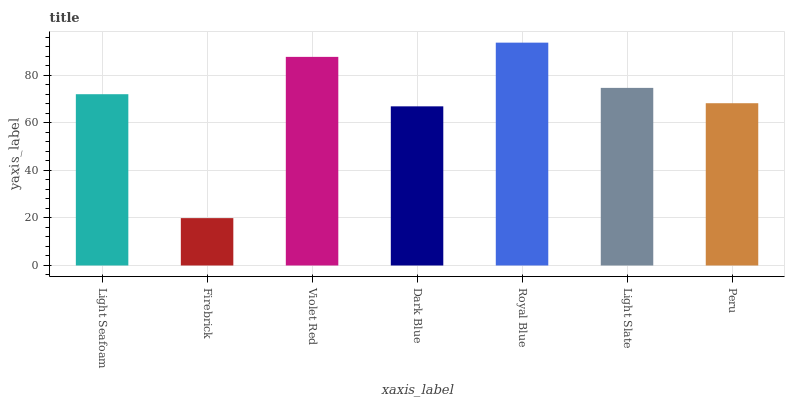Is Violet Red the minimum?
Answer yes or no. No. Is Violet Red the maximum?
Answer yes or no. No. Is Violet Red greater than Firebrick?
Answer yes or no. Yes. Is Firebrick less than Violet Red?
Answer yes or no. Yes. Is Firebrick greater than Violet Red?
Answer yes or no. No. Is Violet Red less than Firebrick?
Answer yes or no. No. Is Light Seafoam the high median?
Answer yes or no. Yes. Is Light Seafoam the low median?
Answer yes or no. Yes. Is Peru the high median?
Answer yes or no. No. Is Dark Blue the low median?
Answer yes or no. No. 